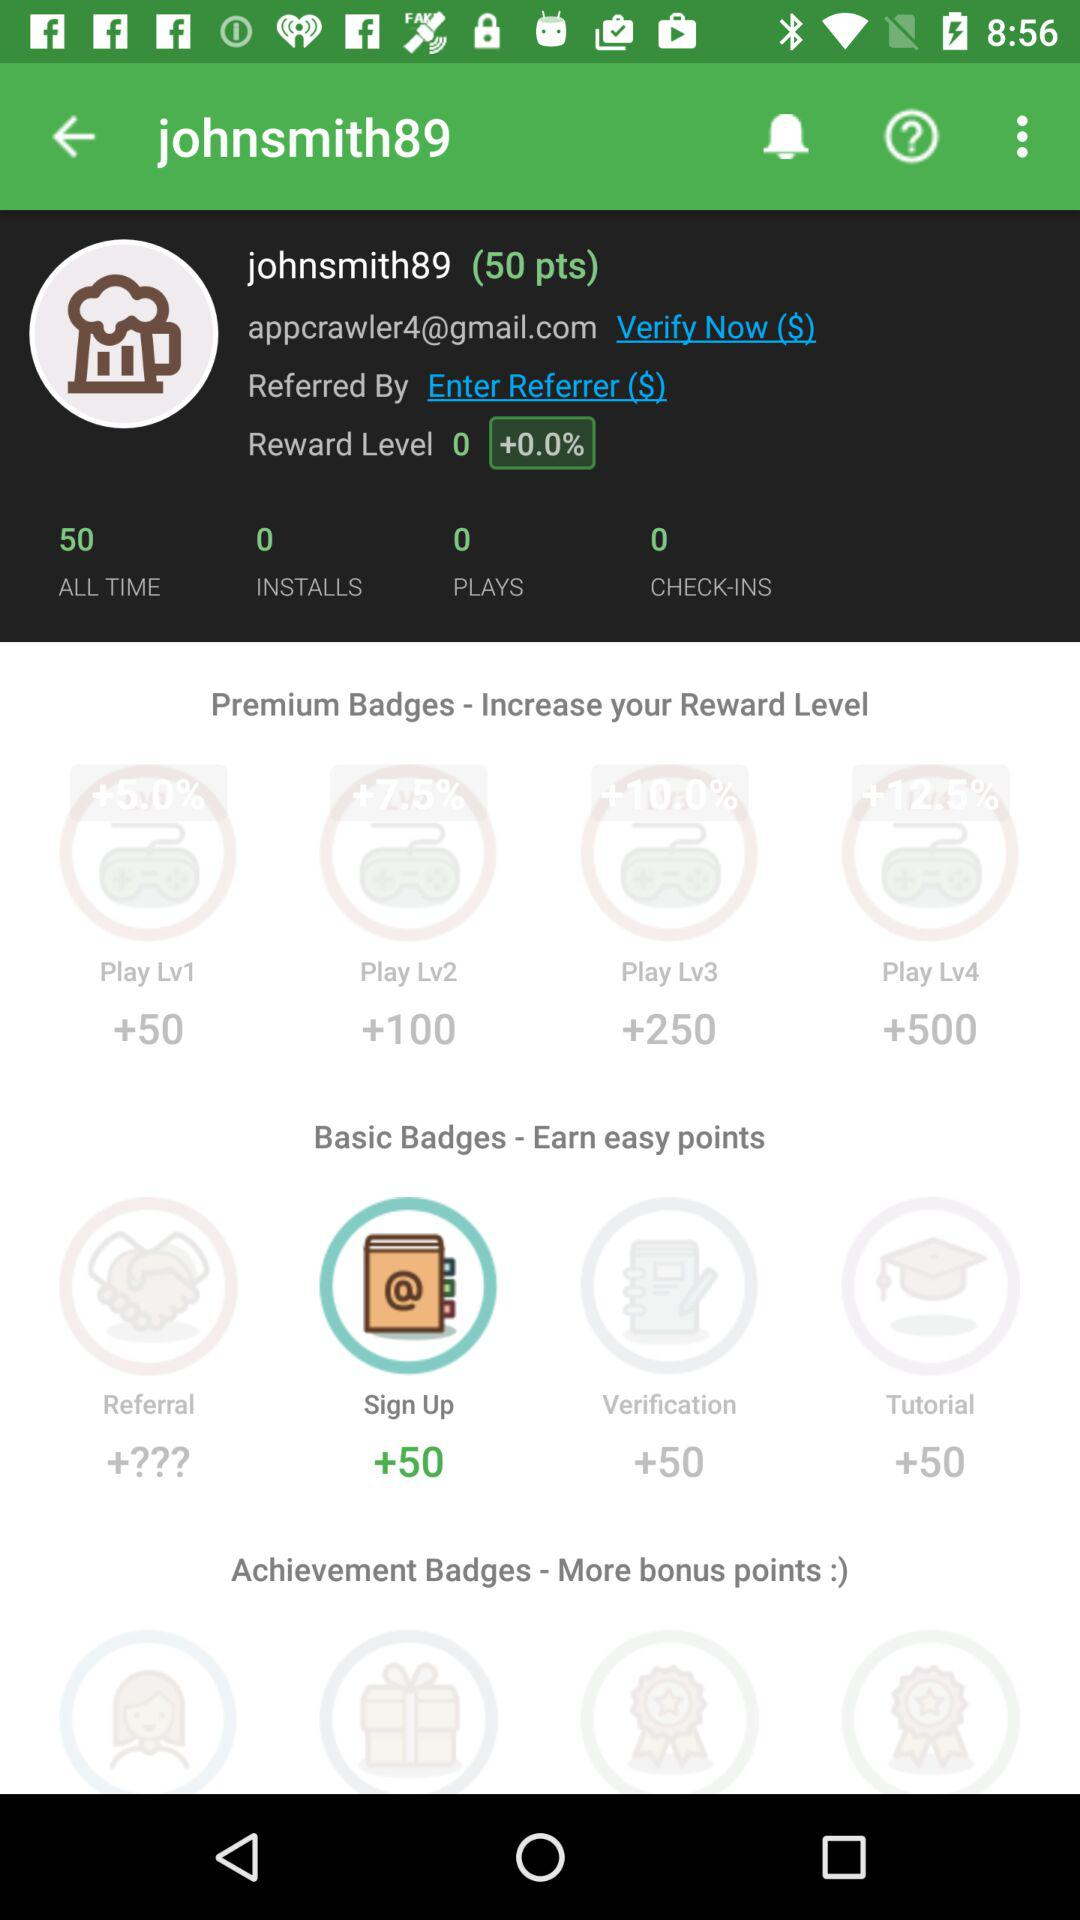What is the email address of a user? The email address is appcrawler4@gmail.com. 